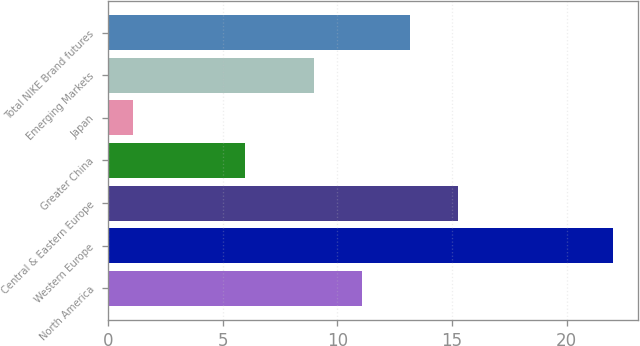<chart> <loc_0><loc_0><loc_500><loc_500><bar_chart><fcel>North America<fcel>Western Europe<fcel>Central & Eastern Europe<fcel>Greater China<fcel>Japan<fcel>Emerging Markets<fcel>Total NIKE Brand futures<nl><fcel>11.09<fcel>22<fcel>15.27<fcel>6<fcel>1.09<fcel>9<fcel>13.18<nl></chart> 